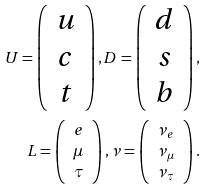<formula> <loc_0><loc_0><loc_500><loc_500>U = \left ( \begin{array} { c } u \\ c \\ t \end{array} \right ) , D = \left ( \begin{array} { c } d \\ s \\ b \end{array} \right ) , \\ L = \left ( \begin{array} { c } e \\ \mu \\ \tau \end{array} \right ) , \nu = \left ( \begin{array} { c } \nu _ { e } \\ \nu _ { \mu } \\ \nu _ { \tau } \end{array} \right ) .</formula> 